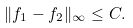Convert formula to latex. <formula><loc_0><loc_0><loc_500><loc_500>\| { f } _ { 1 } - { f } _ { 2 } \| _ { \infty } \leq C .</formula> 